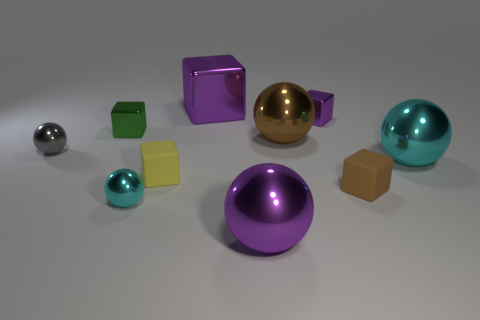There is a small object that is the same color as the big cube; what is its shape?
Your response must be concise. Cube. Is the number of small spheres that are right of the gray thing greater than the number of purple shiny spheres that are behind the small brown thing?
Your answer should be compact. Yes. There is a small metal cube behind the small green object; is its color the same as the big cube?
Offer a terse response. Yes. Is there anything else that has the same color as the big metal block?
Offer a terse response. Yes. Are there more shiny cubes right of the tiny green object than big brown things?
Give a very brief answer. Yes. Do the purple ball and the brown matte block have the same size?
Keep it short and to the point. No. There is a purple object that is the same shape as the gray object; what is its material?
Ensure brevity in your answer.  Metal. Is there any other thing that is the same material as the small brown object?
Provide a succinct answer. Yes. How many yellow objects are rubber cubes or metallic cubes?
Keep it short and to the point. 1. There is a tiny ball on the right side of the green shiny object; what is it made of?
Your response must be concise. Metal. 